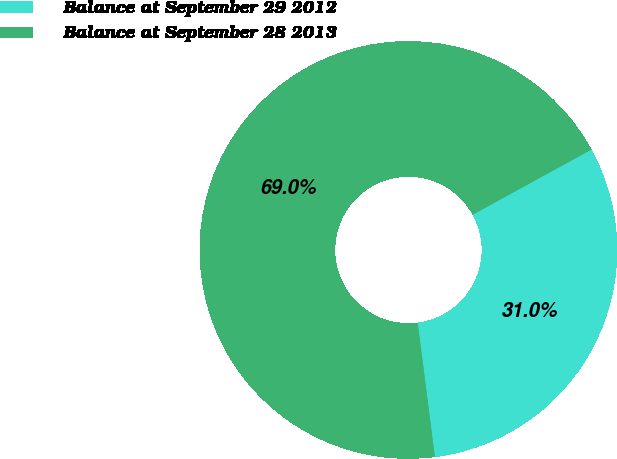<chart> <loc_0><loc_0><loc_500><loc_500><pie_chart><fcel>Balance at September 29 2012<fcel>Balance at September 28 2013<nl><fcel>30.96%<fcel>69.04%<nl></chart> 